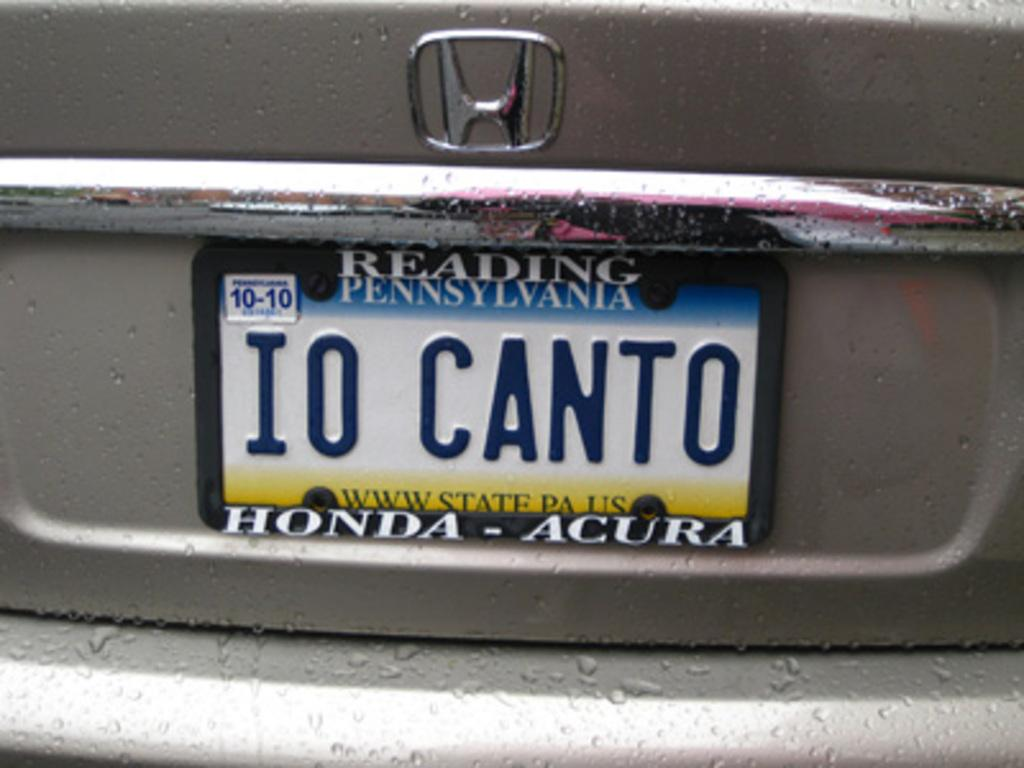<image>
Describe the image concisely. A Pennsylvania license plate has a plate holder from Reading Honda Acura. 